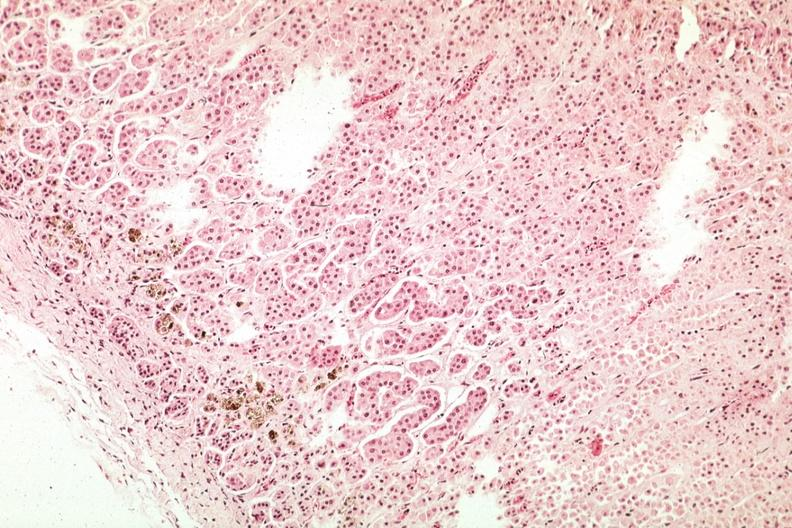how many glomerulosa does this image show pigment in area of?
Answer the question using a single word or phrase. Zona 